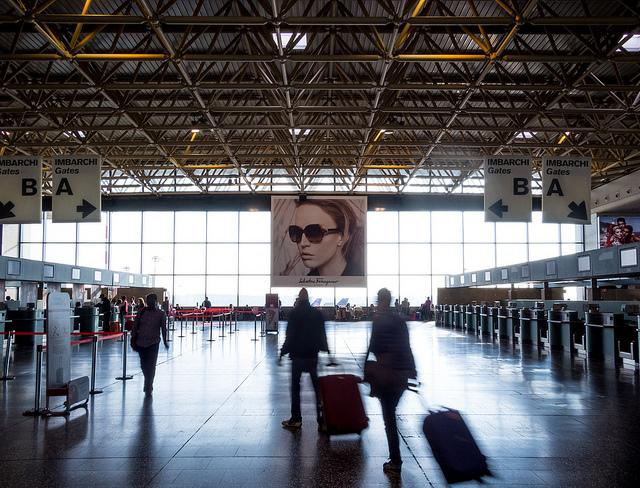This Imbarchi gates are updated as automatic open by using what?

Choices:
A) wood
B) magnet
C) cargos
D) steel magnet 